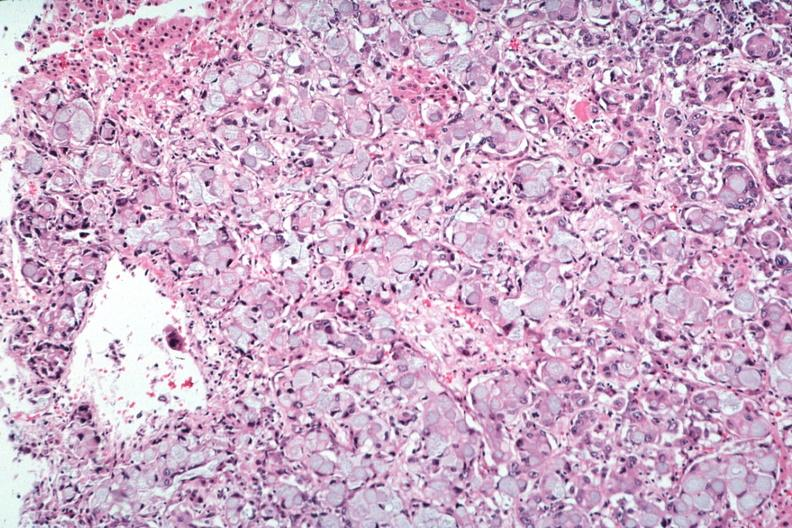what is present?
Answer the question using a single word or phrase. Metastatic carcinoma 